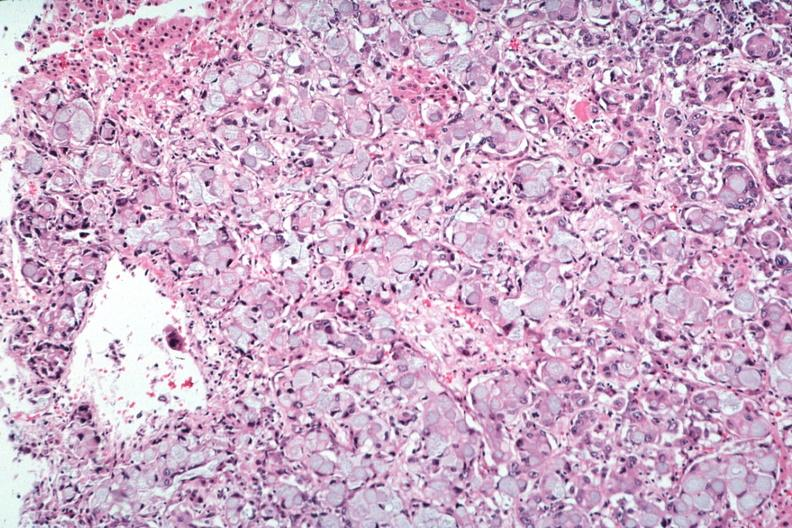what is present?
Answer the question using a single word or phrase. Metastatic carcinoma 